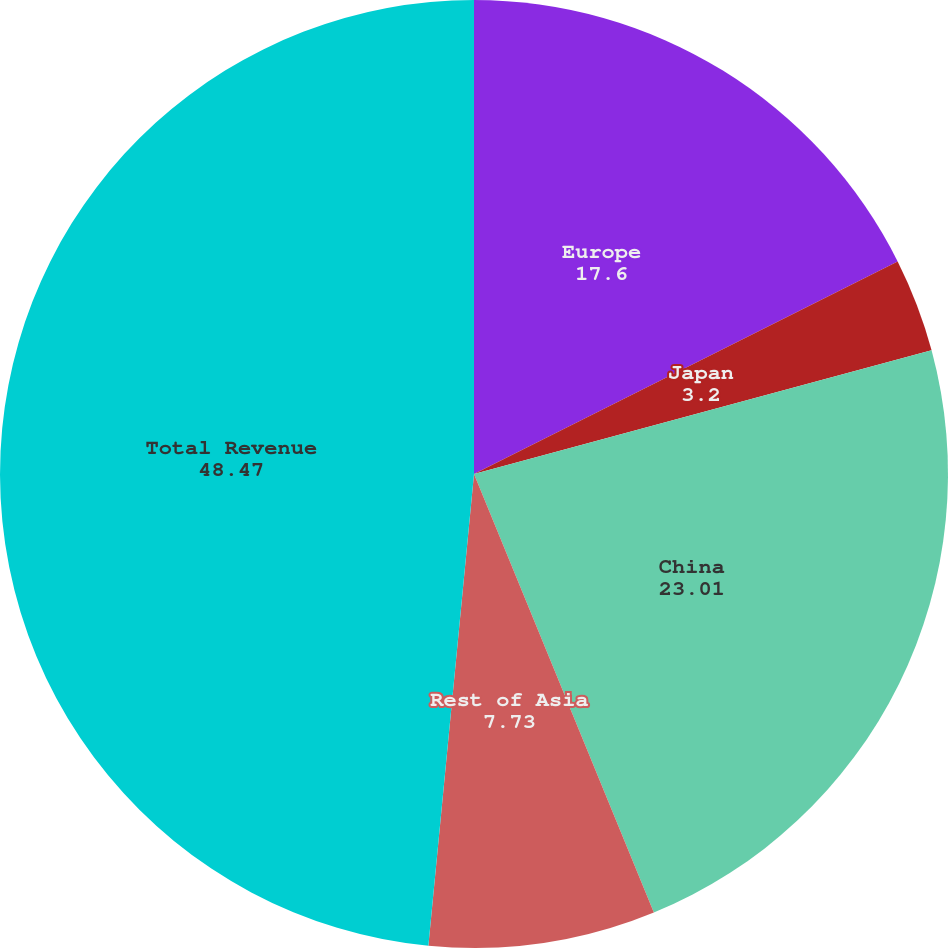<chart> <loc_0><loc_0><loc_500><loc_500><pie_chart><fcel>Europe<fcel>Japan<fcel>China<fcel>Rest of Asia<fcel>Total Revenue<nl><fcel>17.6%<fcel>3.2%<fcel>23.01%<fcel>7.73%<fcel>48.47%<nl></chart> 